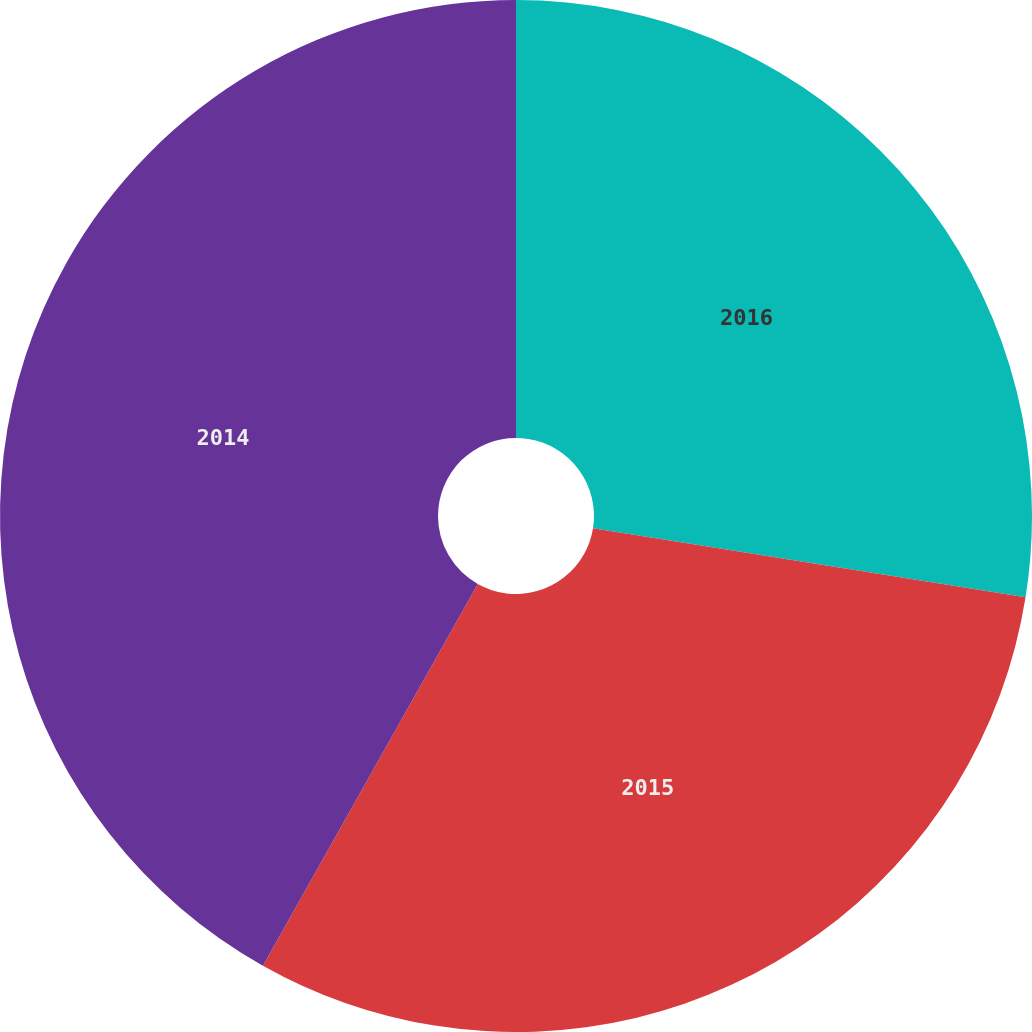<chart> <loc_0><loc_0><loc_500><loc_500><pie_chart><fcel>2016<fcel>2015<fcel>2014<nl><fcel>27.52%<fcel>30.64%<fcel>41.84%<nl></chart> 